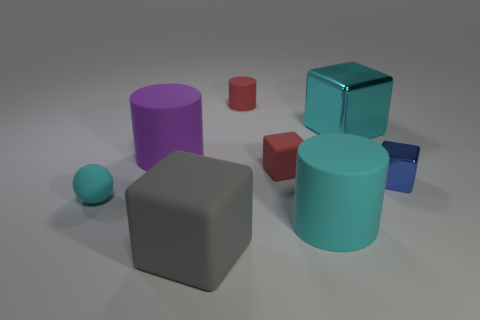Is there a brown metal cylinder?
Give a very brief answer. No. Are there an equal number of tiny blue objects that are in front of the tiny blue shiny thing and gray shiny blocks?
Make the answer very short. Yes. Are there any other things that have the same material as the large gray object?
Offer a very short reply. Yes. How many small things are purple rubber cylinders or red objects?
Provide a succinct answer. 2. There is a big rubber object that is the same color as the tiny rubber sphere; what is its shape?
Make the answer very short. Cylinder. Is the material of the big purple object that is in front of the red cylinder the same as the large gray block?
Provide a succinct answer. Yes. There is a big cylinder left of the small cube that is behind the tiny metallic thing; what is its material?
Make the answer very short. Rubber. What number of other objects have the same shape as the gray object?
Offer a very short reply. 3. There is a blue shiny block that is behind the cyan rubber thing that is right of the cyan rubber object left of the purple matte cylinder; how big is it?
Give a very brief answer. Small. What number of blue objects are big metallic cubes or tiny objects?
Provide a succinct answer. 1. 